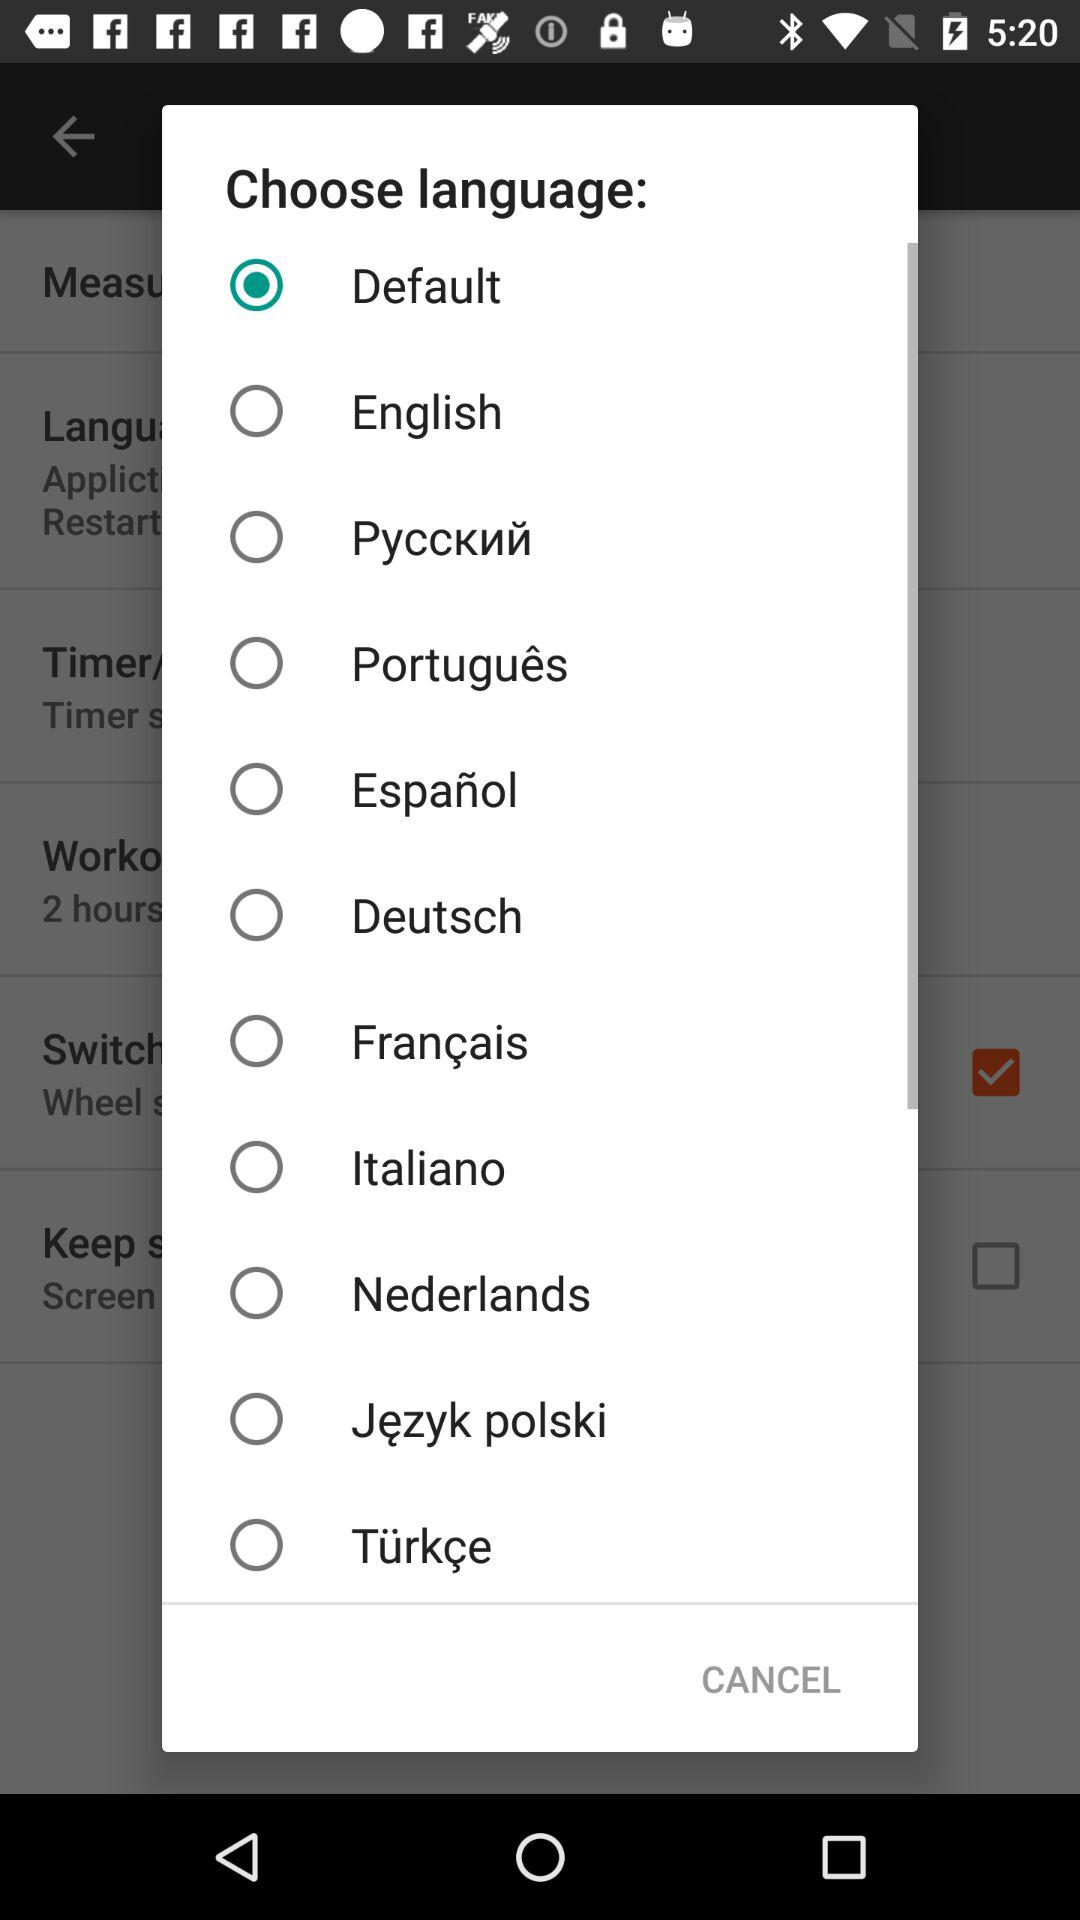Which language option is selected? The selected language option is "Default". 